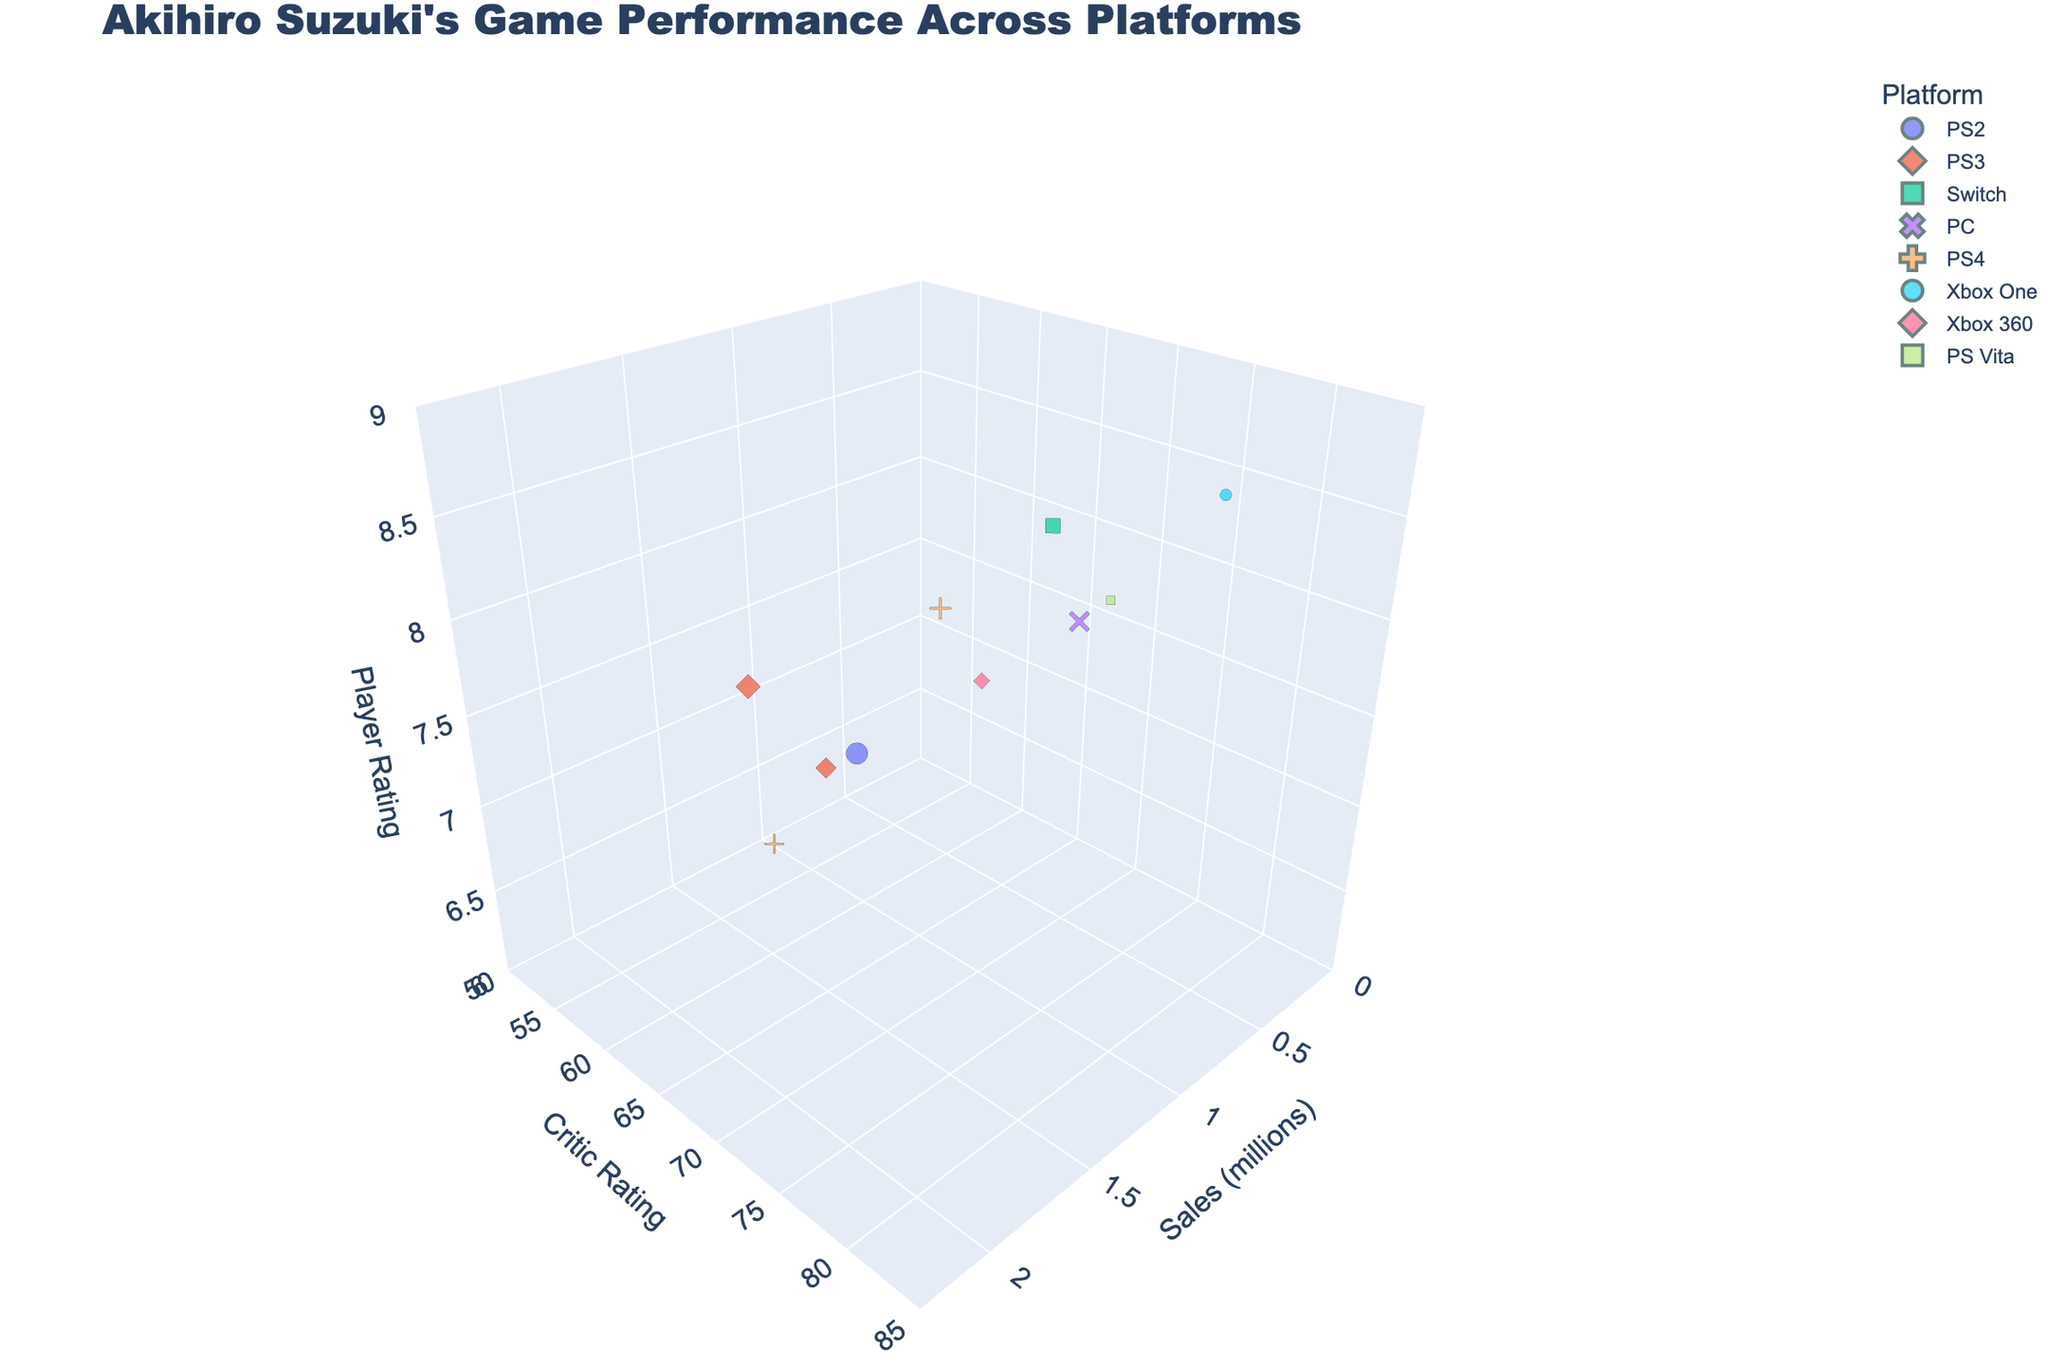what is the title of the figure? The title is typically placed at the top of the figure. Here, it is "Akihiro Suzuki's Game Performance Across Platforms"
Answer: Akihiro Suzuki's Game Performance Across Platforms Which game has the highest player rating? Look at the "Player Rating" axis and find the highest point. The highest player rating appears to be 8.7 for "Samurai Warriors 5" on Xbox One
Answer: Samurai Warriors 5 What is the range of the critic ratings in the figure? The "Critic Rating" axis ranges from 50 to 85 judging by the axis labels and data points
Answer: 50 to 85 How many platforms are represented in the figure? Count the different colors/symbols in the scatter plot's legend representing different platforms. There are seven platforms: PS2, PS3, Switch, PC, PS4, Xbox One, Xbox 360, and PS Vita
Answer: 8 Comparing "Dynasty Warriors 5" and "Dynasty Warriors 9", which has better critic and player ratings? Identify the data points for both games. "Dynasty Warriors 5" has better ratings (Critic Rating: 78, Player Rating: 8.2) compared to "Dynasty Warriors 9" (Critic Rating: 55, Player Rating: 6.3)
Answer: Dynasty Warriors 5 Which platform has the highest cumulative sales? Sum up the sales figures for each platform: PS2 (2.1), PS3 (1.8+1.3), Switch (0.9), PC (0.4), PS4 (1.2+1.5), Xbox One (0.6), Xbox 360 (0.8), PS Vita (0.3). PS4 has the highest cumulative sales of 2.7 million
Answer: PS4 What is the combined critic rating for games on the PS3? Add up the critic ratings for "Dynasty Warriors 8" (65) and "Dynasty Warriors 6" (62). The sum is 65 + 62
Answer: 127 Which game has the lowest sales, and what are its critic and player ratings? Identify the smallest sphere in the plot and hover over it to see the game details. "Warriors All-Stars" on PS Vita has the lowest sales of 0.3 million, with a critic rating of 70 and player rating of 7.8
Answer: Warriors All-Stars, Critic Rating: 70, Player Rating: 7.8 Are there any games with both critic and player ratings above 80? Scan the plot for points where both "Critic Rating" and "Player Rating" exceed 80. "Samurai Warriors 5" on Xbox One fits this condition with ratings Critic: 80, Player: 8.7
Answer: Samurai Warriors 5 